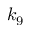Convert formula to latex. <formula><loc_0><loc_0><loc_500><loc_500>k _ { 9 }</formula> 